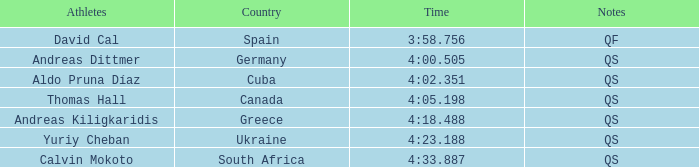What is andreas kiligkaridis' position? 5.0. 